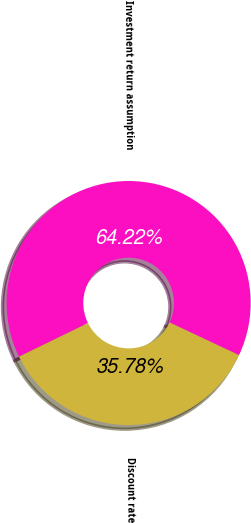Convert chart to OTSL. <chart><loc_0><loc_0><loc_500><loc_500><pie_chart><fcel>Discount rate<fcel>Investment return assumption<nl><fcel>35.78%<fcel>64.22%<nl></chart> 